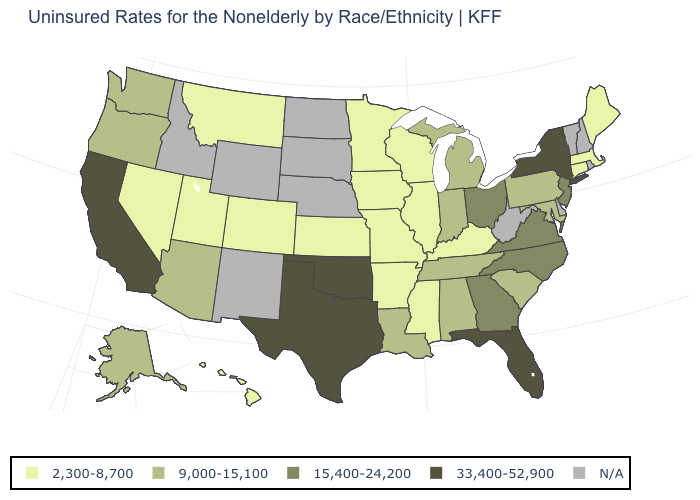Which states have the lowest value in the USA?
Quick response, please. Arkansas, Colorado, Connecticut, Hawaii, Illinois, Iowa, Kansas, Kentucky, Maine, Massachusetts, Minnesota, Mississippi, Missouri, Montana, Nevada, Utah, Wisconsin. Which states hav the highest value in the West?
Give a very brief answer. California. How many symbols are there in the legend?
Keep it brief. 5. What is the value of New Hampshire?
Give a very brief answer. N/A. Does the first symbol in the legend represent the smallest category?
Concise answer only. Yes. What is the highest value in states that border Oklahoma?
Be succinct. 33,400-52,900. Does Kansas have the highest value in the MidWest?
Quick response, please. No. Does the first symbol in the legend represent the smallest category?
Keep it brief. Yes. Does the map have missing data?
Keep it brief. Yes. Name the states that have a value in the range 9,000-15,100?
Keep it brief. Alabama, Alaska, Arizona, Indiana, Louisiana, Maryland, Michigan, Oregon, Pennsylvania, South Carolina, Tennessee, Washington. Name the states that have a value in the range 9,000-15,100?
Be succinct. Alabama, Alaska, Arizona, Indiana, Louisiana, Maryland, Michigan, Oregon, Pennsylvania, South Carolina, Tennessee, Washington. Which states have the lowest value in the South?
Give a very brief answer. Arkansas, Kentucky, Mississippi. What is the lowest value in the Northeast?
Write a very short answer. 2,300-8,700. Does Oklahoma have the highest value in the USA?
Concise answer only. Yes. Which states have the lowest value in the West?
Answer briefly. Colorado, Hawaii, Montana, Nevada, Utah. 